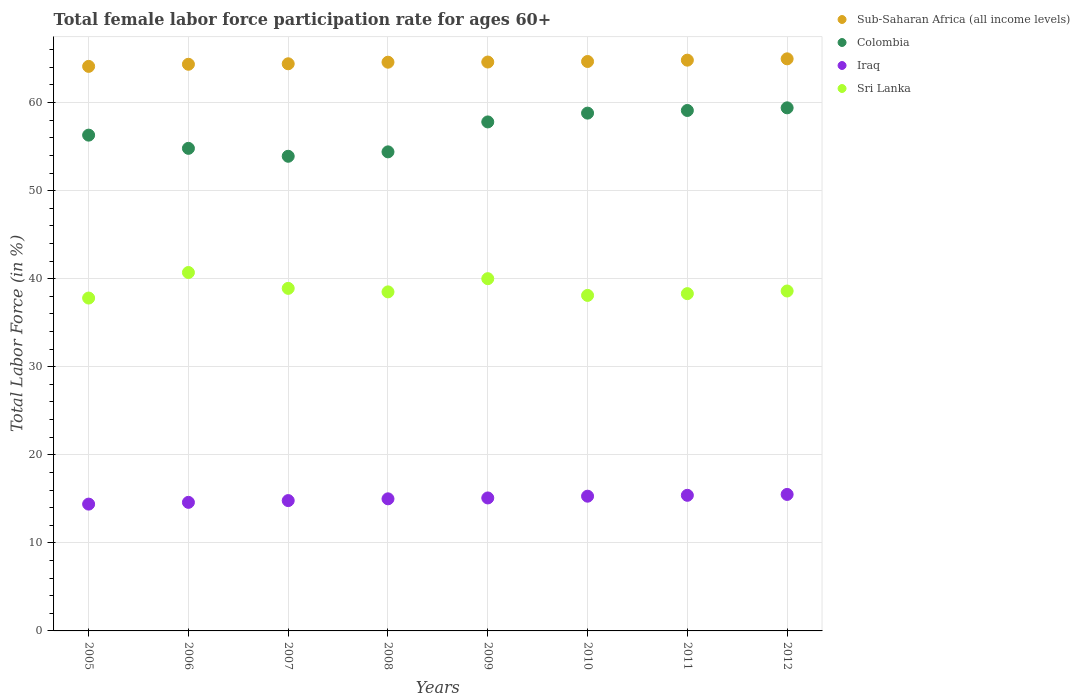How many different coloured dotlines are there?
Offer a very short reply. 4. Is the number of dotlines equal to the number of legend labels?
Ensure brevity in your answer.  Yes. What is the female labor force participation rate in Sub-Saharan Africa (all income levels) in 2010?
Your answer should be compact. 64.66. Across all years, what is the maximum female labor force participation rate in Sri Lanka?
Offer a very short reply. 40.7. Across all years, what is the minimum female labor force participation rate in Sri Lanka?
Ensure brevity in your answer.  37.8. In which year was the female labor force participation rate in Iraq maximum?
Keep it short and to the point. 2012. What is the total female labor force participation rate in Colombia in the graph?
Your answer should be very brief. 454.5. What is the difference between the female labor force participation rate in Sri Lanka in 2007 and that in 2010?
Ensure brevity in your answer.  0.8. What is the difference between the female labor force participation rate in Colombia in 2006 and the female labor force participation rate in Iraq in 2007?
Your answer should be very brief. 40. What is the average female labor force participation rate in Colombia per year?
Provide a short and direct response. 56.81. In the year 2010, what is the difference between the female labor force participation rate in Sri Lanka and female labor force participation rate in Iraq?
Provide a short and direct response. 22.8. What is the ratio of the female labor force participation rate in Sub-Saharan Africa (all income levels) in 2005 to that in 2010?
Make the answer very short. 0.99. Is the difference between the female labor force participation rate in Sri Lanka in 2007 and 2010 greater than the difference between the female labor force participation rate in Iraq in 2007 and 2010?
Make the answer very short. Yes. What is the difference between the highest and the second highest female labor force participation rate in Colombia?
Your answer should be compact. 0.3. What is the difference between the highest and the lowest female labor force participation rate in Iraq?
Offer a very short reply. 1.1. Does the female labor force participation rate in Sri Lanka monotonically increase over the years?
Offer a very short reply. No. Is the female labor force participation rate in Sri Lanka strictly less than the female labor force participation rate in Iraq over the years?
Ensure brevity in your answer.  No. How many dotlines are there?
Ensure brevity in your answer.  4. Where does the legend appear in the graph?
Offer a terse response. Top right. How many legend labels are there?
Offer a very short reply. 4. What is the title of the graph?
Provide a short and direct response. Total female labor force participation rate for ages 60+. What is the Total Labor Force (in %) in Sub-Saharan Africa (all income levels) in 2005?
Make the answer very short. 64.11. What is the Total Labor Force (in %) of Colombia in 2005?
Provide a succinct answer. 56.3. What is the Total Labor Force (in %) of Iraq in 2005?
Offer a very short reply. 14.4. What is the Total Labor Force (in %) of Sri Lanka in 2005?
Give a very brief answer. 37.8. What is the Total Labor Force (in %) of Sub-Saharan Africa (all income levels) in 2006?
Ensure brevity in your answer.  64.35. What is the Total Labor Force (in %) in Colombia in 2006?
Provide a succinct answer. 54.8. What is the Total Labor Force (in %) of Iraq in 2006?
Provide a short and direct response. 14.6. What is the Total Labor Force (in %) of Sri Lanka in 2006?
Give a very brief answer. 40.7. What is the Total Labor Force (in %) of Sub-Saharan Africa (all income levels) in 2007?
Offer a very short reply. 64.4. What is the Total Labor Force (in %) in Colombia in 2007?
Give a very brief answer. 53.9. What is the Total Labor Force (in %) in Iraq in 2007?
Make the answer very short. 14.8. What is the Total Labor Force (in %) of Sri Lanka in 2007?
Your response must be concise. 38.9. What is the Total Labor Force (in %) of Sub-Saharan Africa (all income levels) in 2008?
Keep it short and to the point. 64.58. What is the Total Labor Force (in %) of Colombia in 2008?
Provide a succinct answer. 54.4. What is the Total Labor Force (in %) in Iraq in 2008?
Your answer should be compact. 15. What is the Total Labor Force (in %) in Sri Lanka in 2008?
Provide a short and direct response. 38.5. What is the Total Labor Force (in %) in Sub-Saharan Africa (all income levels) in 2009?
Offer a terse response. 64.6. What is the Total Labor Force (in %) of Colombia in 2009?
Make the answer very short. 57.8. What is the Total Labor Force (in %) of Iraq in 2009?
Provide a short and direct response. 15.1. What is the Total Labor Force (in %) of Sub-Saharan Africa (all income levels) in 2010?
Offer a very short reply. 64.66. What is the Total Labor Force (in %) in Colombia in 2010?
Your answer should be very brief. 58.8. What is the Total Labor Force (in %) in Iraq in 2010?
Your answer should be very brief. 15.3. What is the Total Labor Force (in %) in Sri Lanka in 2010?
Ensure brevity in your answer.  38.1. What is the Total Labor Force (in %) of Sub-Saharan Africa (all income levels) in 2011?
Offer a terse response. 64.81. What is the Total Labor Force (in %) of Colombia in 2011?
Offer a very short reply. 59.1. What is the Total Labor Force (in %) of Iraq in 2011?
Provide a succinct answer. 15.4. What is the Total Labor Force (in %) in Sri Lanka in 2011?
Give a very brief answer. 38.3. What is the Total Labor Force (in %) in Sub-Saharan Africa (all income levels) in 2012?
Give a very brief answer. 64.96. What is the Total Labor Force (in %) in Colombia in 2012?
Your answer should be very brief. 59.4. What is the Total Labor Force (in %) in Sri Lanka in 2012?
Ensure brevity in your answer.  38.6. Across all years, what is the maximum Total Labor Force (in %) in Sub-Saharan Africa (all income levels)?
Your answer should be very brief. 64.96. Across all years, what is the maximum Total Labor Force (in %) of Colombia?
Your answer should be compact. 59.4. Across all years, what is the maximum Total Labor Force (in %) in Sri Lanka?
Offer a very short reply. 40.7. Across all years, what is the minimum Total Labor Force (in %) in Sub-Saharan Africa (all income levels)?
Provide a short and direct response. 64.11. Across all years, what is the minimum Total Labor Force (in %) in Colombia?
Ensure brevity in your answer.  53.9. Across all years, what is the minimum Total Labor Force (in %) in Iraq?
Give a very brief answer. 14.4. Across all years, what is the minimum Total Labor Force (in %) in Sri Lanka?
Provide a succinct answer. 37.8. What is the total Total Labor Force (in %) in Sub-Saharan Africa (all income levels) in the graph?
Provide a short and direct response. 516.49. What is the total Total Labor Force (in %) of Colombia in the graph?
Provide a succinct answer. 454.5. What is the total Total Labor Force (in %) in Iraq in the graph?
Provide a succinct answer. 120.1. What is the total Total Labor Force (in %) of Sri Lanka in the graph?
Ensure brevity in your answer.  310.9. What is the difference between the Total Labor Force (in %) in Sub-Saharan Africa (all income levels) in 2005 and that in 2006?
Ensure brevity in your answer.  -0.24. What is the difference between the Total Labor Force (in %) in Iraq in 2005 and that in 2006?
Give a very brief answer. -0.2. What is the difference between the Total Labor Force (in %) of Sub-Saharan Africa (all income levels) in 2005 and that in 2007?
Make the answer very short. -0.29. What is the difference between the Total Labor Force (in %) of Colombia in 2005 and that in 2007?
Your answer should be very brief. 2.4. What is the difference between the Total Labor Force (in %) of Iraq in 2005 and that in 2007?
Ensure brevity in your answer.  -0.4. What is the difference between the Total Labor Force (in %) of Sub-Saharan Africa (all income levels) in 2005 and that in 2008?
Offer a terse response. -0.48. What is the difference between the Total Labor Force (in %) of Colombia in 2005 and that in 2008?
Your response must be concise. 1.9. What is the difference between the Total Labor Force (in %) in Iraq in 2005 and that in 2008?
Make the answer very short. -0.6. What is the difference between the Total Labor Force (in %) in Sri Lanka in 2005 and that in 2008?
Ensure brevity in your answer.  -0.7. What is the difference between the Total Labor Force (in %) in Sub-Saharan Africa (all income levels) in 2005 and that in 2009?
Your response must be concise. -0.49. What is the difference between the Total Labor Force (in %) in Iraq in 2005 and that in 2009?
Give a very brief answer. -0.7. What is the difference between the Total Labor Force (in %) in Sri Lanka in 2005 and that in 2009?
Provide a succinct answer. -2.2. What is the difference between the Total Labor Force (in %) of Sub-Saharan Africa (all income levels) in 2005 and that in 2010?
Give a very brief answer. -0.56. What is the difference between the Total Labor Force (in %) in Iraq in 2005 and that in 2010?
Your answer should be very brief. -0.9. What is the difference between the Total Labor Force (in %) in Sri Lanka in 2005 and that in 2010?
Your response must be concise. -0.3. What is the difference between the Total Labor Force (in %) in Sub-Saharan Africa (all income levels) in 2005 and that in 2011?
Your response must be concise. -0.71. What is the difference between the Total Labor Force (in %) in Iraq in 2005 and that in 2011?
Offer a terse response. -1. What is the difference between the Total Labor Force (in %) of Sub-Saharan Africa (all income levels) in 2005 and that in 2012?
Your response must be concise. -0.86. What is the difference between the Total Labor Force (in %) in Sri Lanka in 2005 and that in 2012?
Give a very brief answer. -0.8. What is the difference between the Total Labor Force (in %) of Sub-Saharan Africa (all income levels) in 2006 and that in 2007?
Provide a short and direct response. -0.06. What is the difference between the Total Labor Force (in %) in Colombia in 2006 and that in 2007?
Ensure brevity in your answer.  0.9. What is the difference between the Total Labor Force (in %) of Sub-Saharan Africa (all income levels) in 2006 and that in 2008?
Your answer should be compact. -0.24. What is the difference between the Total Labor Force (in %) of Sri Lanka in 2006 and that in 2008?
Keep it short and to the point. 2.2. What is the difference between the Total Labor Force (in %) in Sub-Saharan Africa (all income levels) in 2006 and that in 2009?
Your response must be concise. -0.25. What is the difference between the Total Labor Force (in %) of Colombia in 2006 and that in 2009?
Give a very brief answer. -3. What is the difference between the Total Labor Force (in %) in Iraq in 2006 and that in 2009?
Your answer should be very brief. -0.5. What is the difference between the Total Labor Force (in %) of Sri Lanka in 2006 and that in 2009?
Provide a short and direct response. 0.7. What is the difference between the Total Labor Force (in %) of Sub-Saharan Africa (all income levels) in 2006 and that in 2010?
Your response must be concise. -0.32. What is the difference between the Total Labor Force (in %) in Iraq in 2006 and that in 2010?
Make the answer very short. -0.7. What is the difference between the Total Labor Force (in %) of Sri Lanka in 2006 and that in 2010?
Provide a short and direct response. 2.6. What is the difference between the Total Labor Force (in %) of Sub-Saharan Africa (all income levels) in 2006 and that in 2011?
Your answer should be compact. -0.47. What is the difference between the Total Labor Force (in %) in Sub-Saharan Africa (all income levels) in 2006 and that in 2012?
Provide a succinct answer. -0.62. What is the difference between the Total Labor Force (in %) in Colombia in 2006 and that in 2012?
Provide a succinct answer. -4.6. What is the difference between the Total Labor Force (in %) of Iraq in 2006 and that in 2012?
Your answer should be very brief. -0.9. What is the difference between the Total Labor Force (in %) of Sub-Saharan Africa (all income levels) in 2007 and that in 2008?
Keep it short and to the point. -0.18. What is the difference between the Total Labor Force (in %) of Sri Lanka in 2007 and that in 2008?
Your answer should be very brief. 0.4. What is the difference between the Total Labor Force (in %) of Sub-Saharan Africa (all income levels) in 2007 and that in 2009?
Offer a terse response. -0.2. What is the difference between the Total Labor Force (in %) in Sub-Saharan Africa (all income levels) in 2007 and that in 2010?
Your response must be concise. -0.26. What is the difference between the Total Labor Force (in %) in Sri Lanka in 2007 and that in 2010?
Your response must be concise. 0.8. What is the difference between the Total Labor Force (in %) in Sub-Saharan Africa (all income levels) in 2007 and that in 2011?
Provide a short and direct response. -0.41. What is the difference between the Total Labor Force (in %) of Sub-Saharan Africa (all income levels) in 2007 and that in 2012?
Offer a very short reply. -0.56. What is the difference between the Total Labor Force (in %) of Colombia in 2007 and that in 2012?
Provide a short and direct response. -5.5. What is the difference between the Total Labor Force (in %) of Iraq in 2007 and that in 2012?
Make the answer very short. -0.7. What is the difference between the Total Labor Force (in %) of Sub-Saharan Africa (all income levels) in 2008 and that in 2009?
Offer a terse response. -0.02. What is the difference between the Total Labor Force (in %) in Sri Lanka in 2008 and that in 2009?
Ensure brevity in your answer.  -1.5. What is the difference between the Total Labor Force (in %) in Sub-Saharan Africa (all income levels) in 2008 and that in 2010?
Offer a terse response. -0.08. What is the difference between the Total Labor Force (in %) of Sri Lanka in 2008 and that in 2010?
Provide a short and direct response. 0.4. What is the difference between the Total Labor Force (in %) in Sub-Saharan Africa (all income levels) in 2008 and that in 2011?
Make the answer very short. -0.23. What is the difference between the Total Labor Force (in %) in Colombia in 2008 and that in 2011?
Make the answer very short. -4.7. What is the difference between the Total Labor Force (in %) in Sri Lanka in 2008 and that in 2011?
Ensure brevity in your answer.  0.2. What is the difference between the Total Labor Force (in %) of Sub-Saharan Africa (all income levels) in 2008 and that in 2012?
Offer a terse response. -0.38. What is the difference between the Total Labor Force (in %) in Iraq in 2008 and that in 2012?
Your response must be concise. -0.5. What is the difference between the Total Labor Force (in %) in Sri Lanka in 2008 and that in 2012?
Provide a short and direct response. -0.1. What is the difference between the Total Labor Force (in %) in Sub-Saharan Africa (all income levels) in 2009 and that in 2010?
Provide a succinct answer. -0.06. What is the difference between the Total Labor Force (in %) of Sub-Saharan Africa (all income levels) in 2009 and that in 2011?
Keep it short and to the point. -0.21. What is the difference between the Total Labor Force (in %) in Colombia in 2009 and that in 2011?
Ensure brevity in your answer.  -1.3. What is the difference between the Total Labor Force (in %) in Iraq in 2009 and that in 2011?
Offer a very short reply. -0.3. What is the difference between the Total Labor Force (in %) of Sub-Saharan Africa (all income levels) in 2009 and that in 2012?
Your answer should be compact. -0.36. What is the difference between the Total Labor Force (in %) in Colombia in 2009 and that in 2012?
Provide a succinct answer. -1.6. What is the difference between the Total Labor Force (in %) in Sri Lanka in 2009 and that in 2012?
Offer a very short reply. 1.4. What is the difference between the Total Labor Force (in %) in Sub-Saharan Africa (all income levels) in 2010 and that in 2011?
Your answer should be very brief. -0.15. What is the difference between the Total Labor Force (in %) of Sub-Saharan Africa (all income levels) in 2010 and that in 2012?
Ensure brevity in your answer.  -0.3. What is the difference between the Total Labor Force (in %) in Iraq in 2010 and that in 2012?
Offer a very short reply. -0.2. What is the difference between the Total Labor Force (in %) in Sri Lanka in 2010 and that in 2012?
Your response must be concise. -0.5. What is the difference between the Total Labor Force (in %) of Sub-Saharan Africa (all income levels) in 2011 and that in 2012?
Keep it short and to the point. -0.15. What is the difference between the Total Labor Force (in %) of Colombia in 2011 and that in 2012?
Keep it short and to the point. -0.3. What is the difference between the Total Labor Force (in %) of Sub-Saharan Africa (all income levels) in 2005 and the Total Labor Force (in %) of Colombia in 2006?
Ensure brevity in your answer.  9.31. What is the difference between the Total Labor Force (in %) of Sub-Saharan Africa (all income levels) in 2005 and the Total Labor Force (in %) of Iraq in 2006?
Make the answer very short. 49.51. What is the difference between the Total Labor Force (in %) in Sub-Saharan Africa (all income levels) in 2005 and the Total Labor Force (in %) in Sri Lanka in 2006?
Your answer should be compact. 23.41. What is the difference between the Total Labor Force (in %) in Colombia in 2005 and the Total Labor Force (in %) in Iraq in 2006?
Your response must be concise. 41.7. What is the difference between the Total Labor Force (in %) in Colombia in 2005 and the Total Labor Force (in %) in Sri Lanka in 2006?
Offer a terse response. 15.6. What is the difference between the Total Labor Force (in %) in Iraq in 2005 and the Total Labor Force (in %) in Sri Lanka in 2006?
Ensure brevity in your answer.  -26.3. What is the difference between the Total Labor Force (in %) in Sub-Saharan Africa (all income levels) in 2005 and the Total Labor Force (in %) in Colombia in 2007?
Provide a succinct answer. 10.21. What is the difference between the Total Labor Force (in %) in Sub-Saharan Africa (all income levels) in 2005 and the Total Labor Force (in %) in Iraq in 2007?
Offer a very short reply. 49.31. What is the difference between the Total Labor Force (in %) in Sub-Saharan Africa (all income levels) in 2005 and the Total Labor Force (in %) in Sri Lanka in 2007?
Give a very brief answer. 25.21. What is the difference between the Total Labor Force (in %) in Colombia in 2005 and the Total Labor Force (in %) in Iraq in 2007?
Keep it short and to the point. 41.5. What is the difference between the Total Labor Force (in %) of Colombia in 2005 and the Total Labor Force (in %) of Sri Lanka in 2007?
Keep it short and to the point. 17.4. What is the difference between the Total Labor Force (in %) of Iraq in 2005 and the Total Labor Force (in %) of Sri Lanka in 2007?
Your response must be concise. -24.5. What is the difference between the Total Labor Force (in %) in Sub-Saharan Africa (all income levels) in 2005 and the Total Labor Force (in %) in Colombia in 2008?
Provide a succinct answer. 9.71. What is the difference between the Total Labor Force (in %) in Sub-Saharan Africa (all income levels) in 2005 and the Total Labor Force (in %) in Iraq in 2008?
Offer a very short reply. 49.11. What is the difference between the Total Labor Force (in %) in Sub-Saharan Africa (all income levels) in 2005 and the Total Labor Force (in %) in Sri Lanka in 2008?
Offer a very short reply. 25.61. What is the difference between the Total Labor Force (in %) in Colombia in 2005 and the Total Labor Force (in %) in Iraq in 2008?
Your answer should be compact. 41.3. What is the difference between the Total Labor Force (in %) of Iraq in 2005 and the Total Labor Force (in %) of Sri Lanka in 2008?
Make the answer very short. -24.1. What is the difference between the Total Labor Force (in %) in Sub-Saharan Africa (all income levels) in 2005 and the Total Labor Force (in %) in Colombia in 2009?
Your response must be concise. 6.31. What is the difference between the Total Labor Force (in %) in Sub-Saharan Africa (all income levels) in 2005 and the Total Labor Force (in %) in Iraq in 2009?
Keep it short and to the point. 49.01. What is the difference between the Total Labor Force (in %) of Sub-Saharan Africa (all income levels) in 2005 and the Total Labor Force (in %) of Sri Lanka in 2009?
Your answer should be compact. 24.11. What is the difference between the Total Labor Force (in %) in Colombia in 2005 and the Total Labor Force (in %) in Iraq in 2009?
Offer a terse response. 41.2. What is the difference between the Total Labor Force (in %) in Colombia in 2005 and the Total Labor Force (in %) in Sri Lanka in 2009?
Offer a terse response. 16.3. What is the difference between the Total Labor Force (in %) in Iraq in 2005 and the Total Labor Force (in %) in Sri Lanka in 2009?
Offer a terse response. -25.6. What is the difference between the Total Labor Force (in %) in Sub-Saharan Africa (all income levels) in 2005 and the Total Labor Force (in %) in Colombia in 2010?
Give a very brief answer. 5.31. What is the difference between the Total Labor Force (in %) of Sub-Saharan Africa (all income levels) in 2005 and the Total Labor Force (in %) of Iraq in 2010?
Provide a succinct answer. 48.81. What is the difference between the Total Labor Force (in %) of Sub-Saharan Africa (all income levels) in 2005 and the Total Labor Force (in %) of Sri Lanka in 2010?
Make the answer very short. 26.01. What is the difference between the Total Labor Force (in %) of Iraq in 2005 and the Total Labor Force (in %) of Sri Lanka in 2010?
Offer a very short reply. -23.7. What is the difference between the Total Labor Force (in %) of Sub-Saharan Africa (all income levels) in 2005 and the Total Labor Force (in %) of Colombia in 2011?
Provide a succinct answer. 5.01. What is the difference between the Total Labor Force (in %) in Sub-Saharan Africa (all income levels) in 2005 and the Total Labor Force (in %) in Iraq in 2011?
Provide a succinct answer. 48.71. What is the difference between the Total Labor Force (in %) in Sub-Saharan Africa (all income levels) in 2005 and the Total Labor Force (in %) in Sri Lanka in 2011?
Your response must be concise. 25.81. What is the difference between the Total Labor Force (in %) in Colombia in 2005 and the Total Labor Force (in %) in Iraq in 2011?
Your response must be concise. 40.9. What is the difference between the Total Labor Force (in %) in Colombia in 2005 and the Total Labor Force (in %) in Sri Lanka in 2011?
Provide a succinct answer. 18. What is the difference between the Total Labor Force (in %) in Iraq in 2005 and the Total Labor Force (in %) in Sri Lanka in 2011?
Give a very brief answer. -23.9. What is the difference between the Total Labor Force (in %) in Sub-Saharan Africa (all income levels) in 2005 and the Total Labor Force (in %) in Colombia in 2012?
Provide a succinct answer. 4.71. What is the difference between the Total Labor Force (in %) of Sub-Saharan Africa (all income levels) in 2005 and the Total Labor Force (in %) of Iraq in 2012?
Provide a short and direct response. 48.61. What is the difference between the Total Labor Force (in %) in Sub-Saharan Africa (all income levels) in 2005 and the Total Labor Force (in %) in Sri Lanka in 2012?
Provide a short and direct response. 25.51. What is the difference between the Total Labor Force (in %) in Colombia in 2005 and the Total Labor Force (in %) in Iraq in 2012?
Provide a succinct answer. 40.8. What is the difference between the Total Labor Force (in %) of Colombia in 2005 and the Total Labor Force (in %) of Sri Lanka in 2012?
Your answer should be compact. 17.7. What is the difference between the Total Labor Force (in %) in Iraq in 2005 and the Total Labor Force (in %) in Sri Lanka in 2012?
Your response must be concise. -24.2. What is the difference between the Total Labor Force (in %) of Sub-Saharan Africa (all income levels) in 2006 and the Total Labor Force (in %) of Colombia in 2007?
Make the answer very short. 10.45. What is the difference between the Total Labor Force (in %) of Sub-Saharan Africa (all income levels) in 2006 and the Total Labor Force (in %) of Iraq in 2007?
Offer a terse response. 49.55. What is the difference between the Total Labor Force (in %) in Sub-Saharan Africa (all income levels) in 2006 and the Total Labor Force (in %) in Sri Lanka in 2007?
Ensure brevity in your answer.  25.45. What is the difference between the Total Labor Force (in %) of Iraq in 2006 and the Total Labor Force (in %) of Sri Lanka in 2007?
Offer a terse response. -24.3. What is the difference between the Total Labor Force (in %) in Sub-Saharan Africa (all income levels) in 2006 and the Total Labor Force (in %) in Colombia in 2008?
Make the answer very short. 9.95. What is the difference between the Total Labor Force (in %) of Sub-Saharan Africa (all income levels) in 2006 and the Total Labor Force (in %) of Iraq in 2008?
Give a very brief answer. 49.35. What is the difference between the Total Labor Force (in %) of Sub-Saharan Africa (all income levels) in 2006 and the Total Labor Force (in %) of Sri Lanka in 2008?
Keep it short and to the point. 25.85. What is the difference between the Total Labor Force (in %) of Colombia in 2006 and the Total Labor Force (in %) of Iraq in 2008?
Your answer should be very brief. 39.8. What is the difference between the Total Labor Force (in %) in Iraq in 2006 and the Total Labor Force (in %) in Sri Lanka in 2008?
Offer a very short reply. -23.9. What is the difference between the Total Labor Force (in %) in Sub-Saharan Africa (all income levels) in 2006 and the Total Labor Force (in %) in Colombia in 2009?
Offer a very short reply. 6.55. What is the difference between the Total Labor Force (in %) in Sub-Saharan Africa (all income levels) in 2006 and the Total Labor Force (in %) in Iraq in 2009?
Your response must be concise. 49.25. What is the difference between the Total Labor Force (in %) of Sub-Saharan Africa (all income levels) in 2006 and the Total Labor Force (in %) of Sri Lanka in 2009?
Your answer should be very brief. 24.35. What is the difference between the Total Labor Force (in %) of Colombia in 2006 and the Total Labor Force (in %) of Iraq in 2009?
Your answer should be compact. 39.7. What is the difference between the Total Labor Force (in %) of Colombia in 2006 and the Total Labor Force (in %) of Sri Lanka in 2009?
Make the answer very short. 14.8. What is the difference between the Total Labor Force (in %) of Iraq in 2006 and the Total Labor Force (in %) of Sri Lanka in 2009?
Provide a short and direct response. -25.4. What is the difference between the Total Labor Force (in %) of Sub-Saharan Africa (all income levels) in 2006 and the Total Labor Force (in %) of Colombia in 2010?
Provide a short and direct response. 5.55. What is the difference between the Total Labor Force (in %) in Sub-Saharan Africa (all income levels) in 2006 and the Total Labor Force (in %) in Iraq in 2010?
Offer a terse response. 49.05. What is the difference between the Total Labor Force (in %) of Sub-Saharan Africa (all income levels) in 2006 and the Total Labor Force (in %) of Sri Lanka in 2010?
Offer a terse response. 26.25. What is the difference between the Total Labor Force (in %) in Colombia in 2006 and the Total Labor Force (in %) in Iraq in 2010?
Make the answer very short. 39.5. What is the difference between the Total Labor Force (in %) of Iraq in 2006 and the Total Labor Force (in %) of Sri Lanka in 2010?
Provide a succinct answer. -23.5. What is the difference between the Total Labor Force (in %) of Sub-Saharan Africa (all income levels) in 2006 and the Total Labor Force (in %) of Colombia in 2011?
Provide a short and direct response. 5.25. What is the difference between the Total Labor Force (in %) in Sub-Saharan Africa (all income levels) in 2006 and the Total Labor Force (in %) in Iraq in 2011?
Your response must be concise. 48.95. What is the difference between the Total Labor Force (in %) in Sub-Saharan Africa (all income levels) in 2006 and the Total Labor Force (in %) in Sri Lanka in 2011?
Offer a very short reply. 26.05. What is the difference between the Total Labor Force (in %) of Colombia in 2006 and the Total Labor Force (in %) of Iraq in 2011?
Your response must be concise. 39.4. What is the difference between the Total Labor Force (in %) in Iraq in 2006 and the Total Labor Force (in %) in Sri Lanka in 2011?
Your answer should be very brief. -23.7. What is the difference between the Total Labor Force (in %) in Sub-Saharan Africa (all income levels) in 2006 and the Total Labor Force (in %) in Colombia in 2012?
Your answer should be very brief. 4.95. What is the difference between the Total Labor Force (in %) in Sub-Saharan Africa (all income levels) in 2006 and the Total Labor Force (in %) in Iraq in 2012?
Give a very brief answer. 48.85. What is the difference between the Total Labor Force (in %) in Sub-Saharan Africa (all income levels) in 2006 and the Total Labor Force (in %) in Sri Lanka in 2012?
Your answer should be compact. 25.75. What is the difference between the Total Labor Force (in %) of Colombia in 2006 and the Total Labor Force (in %) of Iraq in 2012?
Keep it short and to the point. 39.3. What is the difference between the Total Labor Force (in %) in Sub-Saharan Africa (all income levels) in 2007 and the Total Labor Force (in %) in Colombia in 2008?
Give a very brief answer. 10. What is the difference between the Total Labor Force (in %) of Sub-Saharan Africa (all income levels) in 2007 and the Total Labor Force (in %) of Iraq in 2008?
Your response must be concise. 49.4. What is the difference between the Total Labor Force (in %) of Sub-Saharan Africa (all income levels) in 2007 and the Total Labor Force (in %) of Sri Lanka in 2008?
Give a very brief answer. 25.9. What is the difference between the Total Labor Force (in %) in Colombia in 2007 and the Total Labor Force (in %) in Iraq in 2008?
Your answer should be compact. 38.9. What is the difference between the Total Labor Force (in %) in Iraq in 2007 and the Total Labor Force (in %) in Sri Lanka in 2008?
Provide a succinct answer. -23.7. What is the difference between the Total Labor Force (in %) of Sub-Saharan Africa (all income levels) in 2007 and the Total Labor Force (in %) of Colombia in 2009?
Provide a succinct answer. 6.6. What is the difference between the Total Labor Force (in %) in Sub-Saharan Africa (all income levels) in 2007 and the Total Labor Force (in %) in Iraq in 2009?
Provide a succinct answer. 49.3. What is the difference between the Total Labor Force (in %) in Sub-Saharan Africa (all income levels) in 2007 and the Total Labor Force (in %) in Sri Lanka in 2009?
Ensure brevity in your answer.  24.4. What is the difference between the Total Labor Force (in %) in Colombia in 2007 and the Total Labor Force (in %) in Iraq in 2009?
Ensure brevity in your answer.  38.8. What is the difference between the Total Labor Force (in %) in Colombia in 2007 and the Total Labor Force (in %) in Sri Lanka in 2009?
Provide a succinct answer. 13.9. What is the difference between the Total Labor Force (in %) of Iraq in 2007 and the Total Labor Force (in %) of Sri Lanka in 2009?
Provide a short and direct response. -25.2. What is the difference between the Total Labor Force (in %) in Sub-Saharan Africa (all income levels) in 2007 and the Total Labor Force (in %) in Colombia in 2010?
Your answer should be compact. 5.6. What is the difference between the Total Labor Force (in %) in Sub-Saharan Africa (all income levels) in 2007 and the Total Labor Force (in %) in Iraq in 2010?
Keep it short and to the point. 49.1. What is the difference between the Total Labor Force (in %) of Sub-Saharan Africa (all income levels) in 2007 and the Total Labor Force (in %) of Sri Lanka in 2010?
Offer a very short reply. 26.3. What is the difference between the Total Labor Force (in %) of Colombia in 2007 and the Total Labor Force (in %) of Iraq in 2010?
Keep it short and to the point. 38.6. What is the difference between the Total Labor Force (in %) of Colombia in 2007 and the Total Labor Force (in %) of Sri Lanka in 2010?
Offer a very short reply. 15.8. What is the difference between the Total Labor Force (in %) of Iraq in 2007 and the Total Labor Force (in %) of Sri Lanka in 2010?
Your answer should be compact. -23.3. What is the difference between the Total Labor Force (in %) in Sub-Saharan Africa (all income levels) in 2007 and the Total Labor Force (in %) in Colombia in 2011?
Your answer should be compact. 5.3. What is the difference between the Total Labor Force (in %) in Sub-Saharan Africa (all income levels) in 2007 and the Total Labor Force (in %) in Iraq in 2011?
Offer a terse response. 49. What is the difference between the Total Labor Force (in %) in Sub-Saharan Africa (all income levels) in 2007 and the Total Labor Force (in %) in Sri Lanka in 2011?
Your answer should be very brief. 26.1. What is the difference between the Total Labor Force (in %) in Colombia in 2007 and the Total Labor Force (in %) in Iraq in 2011?
Your answer should be compact. 38.5. What is the difference between the Total Labor Force (in %) of Iraq in 2007 and the Total Labor Force (in %) of Sri Lanka in 2011?
Provide a short and direct response. -23.5. What is the difference between the Total Labor Force (in %) of Sub-Saharan Africa (all income levels) in 2007 and the Total Labor Force (in %) of Colombia in 2012?
Offer a terse response. 5. What is the difference between the Total Labor Force (in %) of Sub-Saharan Africa (all income levels) in 2007 and the Total Labor Force (in %) of Iraq in 2012?
Provide a short and direct response. 48.9. What is the difference between the Total Labor Force (in %) in Sub-Saharan Africa (all income levels) in 2007 and the Total Labor Force (in %) in Sri Lanka in 2012?
Keep it short and to the point. 25.8. What is the difference between the Total Labor Force (in %) in Colombia in 2007 and the Total Labor Force (in %) in Iraq in 2012?
Provide a short and direct response. 38.4. What is the difference between the Total Labor Force (in %) of Iraq in 2007 and the Total Labor Force (in %) of Sri Lanka in 2012?
Provide a short and direct response. -23.8. What is the difference between the Total Labor Force (in %) in Sub-Saharan Africa (all income levels) in 2008 and the Total Labor Force (in %) in Colombia in 2009?
Ensure brevity in your answer.  6.78. What is the difference between the Total Labor Force (in %) of Sub-Saharan Africa (all income levels) in 2008 and the Total Labor Force (in %) of Iraq in 2009?
Make the answer very short. 49.48. What is the difference between the Total Labor Force (in %) of Sub-Saharan Africa (all income levels) in 2008 and the Total Labor Force (in %) of Sri Lanka in 2009?
Your answer should be compact. 24.58. What is the difference between the Total Labor Force (in %) in Colombia in 2008 and the Total Labor Force (in %) in Iraq in 2009?
Your answer should be compact. 39.3. What is the difference between the Total Labor Force (in %) in Colombia in 2008 and the Total Labor Force (in %) in Sri Lanka in 2009?
Your answer should be compact. 14.4. What is the difference between the Total Labor Force (in %) of Iraq in 2008 and the Total Labor Force (in %) of Sri Lanka in 2009?
Give a very brief answer. -25. What is the difference between the Total Labor Force (in %) in Sub-Saharan Africa (all income levels) in 2008 and the Total Labor Force (in %) in Colombia in 2010?
Provide a succinct answer. 5.78. What is the difference between the Total Labor Force (in %) of Sub-Saharan Africa (all income levels) in 2008 and the Total Labor Force (in %) of Iraq in 2010?
Your response must be concise. 49.28. What is the difference between the Total Labor Force (in %) in Sub-Saharan Africa (all income levels) in 2008 and the Total Labor Force (in %) in Sri Lanka in 2010?
Keep it short and to the point. 26.48. What is the difference between the Total Labor Force (in %) of Colombia in 2008 and the Total Labor Force (in %) of Iraq in 2010?
Your answer should be compact. 39.1. What is the difference between the Total Labor Force (in %) of Iraq in 2008 and the Total Labor Force (in %) of Sri Lanka in 2010?
Provide a short and direct response. -23.1. What is the difference between the Total Labor Force (in %) in Sub-Saharan Africa (all income levels) in 2008 and the Total Labor Force (in %) in Colombia in 2011?
Ensure brevity in your answer.  5.48. What is the difference between the Total Labor Force (in %) of Sub-Saharan Africa (all income levels) in 2008 and the Total Labor Force (in %) of Iraq in 2011?
Keep it short and to the point. 49.18. What is the difference between the Total Labor Force (in %) of Sub-Saharan Africa (all income levels) in 2008 and the Total Labor Force (in %) of Sri Lanka in 2011?
Provide a succinct answer. 26.28. What is the difference between the Total Labor Force (in %) of Iraq in 2008 and the Total Labor Force (in %) of Sri Lanka in 2011?
Your response must be concise. -23.3. What is the difference between the Total Labor Force (in %) in Sub-Saharan Africa (all income levels) in 2008 and the Total Labor Force (in %) in Colombia in 2012?
Your answer should be very brief. 5.18. What is the difference between the Total Labor Force (in %) of Sub-Saharan Africa (all income levels) in 2008 and the Total Labor Force (in %) of Iraq in 2012?
Give a very brief answer. 49.08. What is the difference between the Total Labor Force (in %) of Sub-Saharan Africa (all income levels) in 2008 and the Total Labor Force (in %) of Sri Lanka in 2012?
Your answer should be very brief. 25.98. What is the difference between the Total Labor Force (in %) of Colombia in 2008 and the Total Labor Force (in %) of Iraq in 2012?
Provide a short and direct response. 38.9. What is the difference between the Total Labor Force (in %) in Colombia in 2008 and the Total Labor Force (in %) in Sri Lanka in 2012?
Provide a short and direct response. 15.8. What is the difference between the Total Labor Force (in %) of Iraq in 2008 and the Total Labor Force (in %) of Sri Lanka in 2012?
Make the answer very short. -23.6. What is the difference between the Total Labor Force (in %) in Sub-Saharan Africa (all income levels) in 2009 and the Total Labor Force (in %) in Colombia in 2010?
Offer a very short reply. 5.8. What is the difference between the Total Labor Force (in %) in Sub-Saharan Africa (all income levels) in 2009 and the Total Labor Force (in %) in Iraq in 2010?
Offer a terse response. 49.3. What is the difference between the Total Labor Force (in %) of Sub-Saharan Africa (all income levels) in 2009 and the Total Labor Force (in %) of Sri Lanka in 2010?
Your answer should be very brief. 26.5. What is the difference between the Total Labor Force (in %) of Colombia in 2009 and the Total Labor Force (in %) of Iraq in 2010?
Keep it short and to the point. 42.5. What is the difference between the Total Labor Force (in %) in Colombia in 2009 and the Total Labor Force (in %) in Sri Lanka in 2010?
Offer a very short reply. 19.7. What is the difference between the Total Labor Force (in %) in Iraq in 2009 and the Total Labor Force (in %) in Sri Lanka in 2010?
Your answer should be very brief. -23. What is the difference between the Total Labor Force (in %) of Sub-Saharan Africa (all income levels) in 2009 and the Total Labor Force (in %) of Colombia in 2011?
Give a very brief answer. 5.5. What is the difference between the Total Labor Force (in %) in Sub-Saharan Africa (all income levels) in 2009 and the Total Labor Force (in %) in Iraq in 2011?
Provide a short and direct response. 49.2. What is the difference between the Total Labor Force (in %) in Sub-Saharan Africa (all income levels) in 2009 and the Total Labor Force (in %) in Sri Lanka in 2011?
Give a very brief answer. 26.3. What is the difference between the Total Labor Force (in %) of Colombia in 2009 and the Total Labor Force (in %) of Iraq in 2011?
Ensure brevity in your answer.  42.4. What is the difference between the Total Labor Force (in %) of Colombia in 2009 and the Total Labor Force (in %) of Sri Lanka in 2011?
Offer a very short reply. 19.5. What is the difference between the Total Labor Force (in %) of Iraq in 2009 and the Total Labor Force (in %) of Sri Lanka in 2011?
Your response must be concise. -23.2. What is the difference between the Total Labor Force (in %) in Sub-Saharan Africa (all income levels) in 2009 and the Total Labor Force (in %) in Colombia in 2012?
Provide a succinct answer. 5.2. What is the difference between the Total Labor Force (in %) in Sub-Saharan Africa (all income levels) in 2009 and the Total Labor Force (in %) in Iraq in 2012?
Your answer should be compact. 49.1. What is the difference between the Total Labor Force (in %) in Sub-Saharan Africa (all income levels) in 2009 and the Total Labor Force (in %) in Sri Lanka in 2012?
Give a very brief answer. 26. What is the difference between the Total Labor Force (in %) of Colombia in 2009 and the Total Labor Force (in %) of Iraq in 2012?
Your answer should be very brief. 42.3. What is the difference between the Total Labor Force (in %) of Iraq in 2009 and the Total Labor Force (in %) of Sri Lanka in 2012?
Your answer should be compact. -23.5. What is the difference between the Total Labor Force (in %) in Sub-Saharan Africa (all income levels) in 2010 and the Total Labor Force (in %) in Colombia in 2011?
Your response must be concise. 5.56. What is the difference between the Total Labor Force (in %) in Sub-Saharan Africa (all income levels) in 2010 and the Total Labor Force (in %) in Iraq in 2011?
Make the answer very short. 49.26. What is the difference between the Total Labor Force (in %) of Sub-Saharan Africa (all income levels) in 2010 and the Total Labor Force (in %) of Sri Lanka in 2011?
Your answer should be compact. 26.36. What is the difference between the Total Labor Force (in %) in Colombia in 2010 and the Total Labor Force (in %) in Iraq in 2011?
Provide a succinct answer. 43.4. What is the difference between the Total Labor Force (in %) of Iraq in 2010 and the Total Labor Force (in %) of Sri Lanka in 2011?
Your answer should be compact. -23. What is the difference between the Total Labor Force (in %) of Sub-Saharan Africa (all income levels) in 2010 and the Total Labor Force (in %) of Colombia in 2012?
Keep it short and to the point. 5.26. What is the difference between the Total Labor Force (in %) in Sub-Saharan Africa (all income levels) in 2010 and the Total Labor Force (in %) in Iraq in 2012?
Provide a short and direct response. 49.16. What is the difference between the Total Labor Force (in %) in Sub-Saharan Africa (all income levels) in 2010 and the Total Labor Force (in %) in Sri Lanka in 2012?
Give a very brief answer. 26.06. What is the difference between the Total Labor Force (in %) in Colombia in 2010 and the Total Labor Force (in %) in Iraq in 2012?
Offer a terse response. 43.3. What is the difference between the Total Labor Force (in %) of Colombia in 2010 and the Total Labor Force (in %) of Sri Lanka in 2012?
Give a very brief answer. 20.2. What is the difference between the Total Labor Force (in %) of Iraq in 2010 and the Total Labor Force (in %) of Sri Lanka in 2012?
Keep it short and to the point. -23.3. What is the difference between the Total Labor Force (in %) of Sub-Saharan Africa (all income levels) in 2011 and the Total Labor Force (in %) of Colombia in 2012?
Make the answer very short. 5.41. What is the difference between the Total Labor Force (in %) in Sub-Saharan Africa (all income levels) in 2011 and the Total Labor Force (in %) in Iraq in 2012?
Your answer should be very brief. 49.31. What is the difference between the Total Labor Force (in %) of Sub-Saharan Africa (all income levels) in 2011 and the Total Labor Force (in %) of Sri Lanka in 2012?
Ensure brevity in your answer.  26.21. What is the difference between the Total Labor Force (in %) of Colombia in 2011 and the Total Labor Force (in %) of Iraq in 2012?
Your answer should be very brief. 43.6. What is the difference between the Total Labor Force (in %) of Colombia in 2011 and the Total Labor Force (in %) of Sri Lanka in 2012?
Keep it short and to the point. 20.5. What is the difference between the Total Labor Force (in %) of Iraq in 2011 and the Total Labor Force (in %) of Sri Lanka in 2012?
Make the answer very short. -23.2. What is the average Total Labor Force (in %) in Sub-Saharan Africa (all income levels) per year?
Provide a short and direct response. 64.56. What is the average Total Labor Force (in %) in Colombia per year?
Ensure brevity in your answer.  56.81. What is the average Total Labor Force (in %) of Iraq per year?
Offer a very short reply. 15.01. What is the average Total Labor Force (in %) in Sri Lanka per year?
Ensure brevity in your answer.  38.86. In the year 2005, what is the difference between the Total Labor Force (in %) in Sub-Saharan Africa (all income levels) and Total Labor Force (in %) in Colombia?
Your response must be concise. 7.81. In the year 2005, what is the difference between the Total Labor Force (in %) of Sub-Saharan Africa (all income levels) and Total Labor Force (in %) of Iraq?
Give a very brief answer. 49.71. In the year 2005, what is the difference between the Total Labor Force (in %) of Sub-Saharan Africa (all income levels) and Total Labor Force (in %) of Sri Lanka?
Offer a very short reply. 26.31. In the year 2005, what is the difference between the Total Labor Force (in %) of Colombia and Total Labor Force (in %) of Iraq?
Ensure brevity in your answer.  41.9. In the year 2005, what is the difference between the Total Labor Force (in %) in Colombia and Total Labor Force (in %) in Sri Lanka?
Your response must be concise. 18.5. In the year 2005, what is the difference between the Total Labor Force (in %) in Iraq and Total Labor Force (in %) in Sri Lanka?
Offer a very short reply. -23.4. In the year 2006, what is the difference between the Total Labor Force (in %) of Sub-Saharan Africa (all income levels) and Total Labor Force (in %) of Colombia?
Give a very brief answer. 9.55. In the year 2006, what is the difference between the Total Labor Force (in %) of Sub-Saharan Africa (all income levels) and Total Labor Force (in %) of Iraq?
Your answer should be very brief. 49.75. In the year 2006, what is the difference between the Total Labor Force (in %) in Sub-Saharan Africa (all income levels) and Total Labor Force (in %) in Sri Lanka?
Your answer should be very brief. 23.65. In the year 2006, what is the difference between the Total Labor Force (in %) of Colombia and Total Labor Force (in %) of Iraq?
Offer a terse response. 40.2. In the year 2006, what is the difference between the Total Labor Force (in %) in Iraq and Total Labor Force (in %) in Sri Lanka?
Your response must be concise. -26.1. In the year 2007, what is the difference between the Total Labor Force (in %) of Sub-Saharan Africa (all income levels) and Total Labor Force (in %) of Colombia?
Your answer should be compact. 10.5. In the year 2007, what is the difference between the Total Labor Force (in %) of Sub-Saharan Africa (all income levels) and Total Labor Force (in %) of Iraq?
Give a very brief answer. 49.6. In the year 2007, what is the difference between the Total Labor Force (in %) in Sub-Saharan Africa (all income levels) and Total Labor Force (in %) in Sri Lanka?
Offer a terse response. 25.5. In the year 2007, what is the difference between the Total Labor Force (in %) in Colombia and Total Labor Force (in %) in Iraq?
Offer a terse response. 39.1. In the year 2007, what is the difference between the Total Labor Force (in %) in Iraq and Total Labor Force (in %) in Sri Lanka?
Provide a short and direct response. -24.1. In the year 2008, what is the difference between the Total Labor Force (in %) of Sub-Saharan Africa (all income levels) and Total Labor Force (in %) of Colombia?
Offer a terse response. 10.18. In the year 2008, what is the difference between the Total Labor Force (in %) in Sub-Saharan Africa (all income levels) and Total Labor Force (in %) in Iraq?
Give a very brief answer. 49.58. In the year 2008, what is the difference between the Total Labor Force (in %) in Sub-Saharan Africa (all income levels) and Total Labor Force (in %) in Sri Lanka?
Provide a short and direct response. 26.08. In the year 2008, what is the difference between the Total Labor Force (in %) of Colombia and Total Labor Force (in %) of Iraq?
Offer a very short reply. 39.4. In the year 2008, what is the difference between the Total Labor Force (in %) of Colombia and Total Labor Force (in %) of Sri Lanka?
Offer a very short reply. 15.9. In the year 2008, what is the difference between the Total Labor Force (in %) in Iraq and Total Labor Force (in %) in Sri Lanka?
Keep it short and to the point. -23.5. In the year 2009, what is the difference between the Total Labor Force (in %) of Sub-Saharan Africa (all income levels) and Total Labor Force (in %) of Colombia?
Make the answer very short. 6.8. In the year 2009, what is the difference between the Total Labor Force (in %) of Sub-Saharan Africa (all income levels) and Total Labor Force (in %) of Iraq?
Your response must be concise. 49.5. In the year 2009, what is the difference between the Total Labor Force (in %) of Sub-Saharan Africa (all income levels) and Total Labor Force (in %) of Sri Lanka?
Your answer should be compact. 24.6. In the year 2009, what is the difference between the Total Labor Force (in %) of Colombia and Total Labor Force (in %) of Iraq?
Provide a short and direct response. 42.7. In the year 2009, what is the difference between the Total Labor Force (in %) in Iraq and Total Labor Force (in %) in Sri Lanka?
Ensure brevity in your answer.  -24.9. In the year 2010, what is the difference between the Total Labor Force (in %) in Sub-Saharan Africa (all income levels) and Total Labor Force (in %) in Colombia?
Offer a very short reply. 5.86. In the year 2010, what is the difference between the Total Labor Force (in %) in Sub-Saharan Africa (all income levels) and Total Labor Force (in %) in Iraq?
Your response must be concise. 49.36. In the year 2010, what is the difference between the Total Labor Force (in %) in Sub-Saharan Africa (all income levels) and Total Labor Force (in %) in Sri Lanka?
Offer a terse response. 26.56. In the year 2010, what is the difference between the Total Labor Force (in %) of Colombia and Total Labor Force (in %) of Iraq?
Offer a terse response. 43.5. In the year 2010, what is the difference between the Total Labor Force (in %) in Colombia and Total Labor Force (in %) in Sri Lanka?
Provide a short and direct response. 20.7. In the year 2010, what is the difference between the Total Labor Force (in %) of Iraq and Total Labor Force (in %) of Sri Lanka?
Your answer should be very brief. -22.8. In the year 2011, what is the difference between the Total Labor Force (in %) in Sub-Saharan Africa (all income levels) and Total Labor Force (in %) in Colombia?
Your response must be concise. 5.71. In the year 2011, what is the difference between the Total Labor Force (in %) of Sub-Saharan Africa (all income levels) and Total Labor Force (in %) of Iraq?
Your answer should be compact. 49.41. In the year 2011, what is the difference between the Total Labor Force (in %) of Sub-Saharan Africa (all income levels) and Total Labor Force (in %) of Sri Lanka?
Offer a very short reply. 26.51. In the year 2011, what is the difference between the Total Labor Force (in %) of Colombia and Total Labor Force (in %) of Iraq?
Ensure brevity in your answer.  43.7. In the year 2011, what is the difference between the Total Labor Force (in %) of Colombia and Total Labor Force (in %) of Sri Lanka?
Make the answer very short. 20.8. In the year 2011, what is the difference between the Total Labor Force (in %) of Iraq and Total Labor Force (in %) of Sri Lanka?
Your answer should be very brief. -22.9. In the year 2012, what is the difference between the Total Labor Force (in %) of Sub-Saharan Africa (all income levels) and Total Labor Force (in %) of Colombia?
Make the answer very short. 5.56. In the year 2012, what is the difference between the Total Labor Force (in %) of Sub-Saharan Africa (all income levels) and Total Labor Force (in %) of Iraq?
Provide a succinct answer. 49.46. In the year 2012, what is the difference between the Total Labor Force (in %) of Sub-Saharan Africa (all income levels) and Total Labor Force (in %) of Sri Lanka?
Provide a short and direct response. 26.36. In the year 2012, what is the difference between the Total Labor Force (in %) of Colombia and Total Labor Force (in %) of Iraq?
Your answer should be very brief. 43.9. In the year 2012, what is the difference between the Total Labor Force (in %) of Colombia and Total Labor Force (in %) of Sri Lanka?
Provide a succinct answer. 20.8. In the year 2012, what is the difference between the Total Labor Force (in %) of Iraq and Total Labor Force (in %) of Sri Lanka?
Offer a terse response. -23.1. What is the ratio of the Total Labor Force (in %) in Sub-Saharan Africa (all income levels) in 2005 to that in 2006?
Your answer should be compact. 1. What is the ratio of the Total Labor Force (in %) of Colombia in 2005 to that in 2006?
Keep it short and to the point. 1.03. What is the ratio of the Total Labor Force (in %) in Iraq in 2005 to that in 2006?
Provide a succinct answer. 0.99. What is the ratio of the Total Labor Force (in %) in Sri Lanka in 2005 to that in 2006?
Offer a terse response. 0.93. What is the ratio of the Total Labor Force (in %) of Colombia in 2005 to that in 2007?
Ensure brevity in your answer.  1.04. What is the ratio of the Total Labor Force (in %) in Sri Lanka in 2005 to that in 2007?
Your response must be concise. 0.97. What is the ratio of the Total Labor Force (in %) of Sub-Saharan Africa (all income levels) in 2005 to that in 2008?
Make the answer very short. 0.99. What is the ratio of the Total Labor Force (in %) of Colombia in 2005 to that in 2008?
Give a very brief answer. 1.03. What is the ratio of the Total Labor Force (in %) of Sri Lanka in 2005 to that in 2008?
Your answer should be compact. 0.98. What is the ratio of the Total Labor Force (in %) of Sub-Saharan Africa (all income levels) in 2005 to that in 2009?
Your answer should be very brief. 0.99. What is the ratio of the Total Labor Force (in %) in Iraq in 2005 to that in 2009?
Your answer should be compact. 0.95. What is the ratio of the Total Labor Force (in %) of Sri Lanka in 2005 to that in 2009?
Provide a succinct answer. 0.94. What is the ratio of the Total Labor Force (in %) of Colombia in 2005 to that in 2010?
Your answer should be very brief. 0.96. What is the ratio of the Total Labor Force (in %) of Iraq in 2005 to that in 2010?
Provide a short and direct response. 0.94. What is the ratio of the Total Labor Force (in %) of Sub-Saharan Africa (all income levels) in 2005 to that in 2011?
Provide a succinct answer. 0.99. What is the ratio of the Total Labor Force (in %) of Colombia in 2005 to that in 2011?
Make the answer very short. 0.95. What is the ratio of the Total Labor Force (in %) of Iraq in 2005 to that in 2011?
Offer a terse response. 0.94. What is the ratio of the Total Labor Force (in %) in Sri Lanka in 2005 to that in 2011?
Your answer should be compact. 0.99. What is the ratio of the Total Labor Force (in %) of Colombia in 2005 to that in 2012?
Offer a terse response. 0.95. What is the ratio of the Total Labor Force (in %) of Iraq in 2005 to that in 2012?
Make the answer very short. 0.93. What is the ratio of the Total Labor Force (in %) of Sri Lanka in 2005 to that in 2012?
Give a very brief answer. 0.98. What is the ratio of the Total Labor Force (in %) of Sub-Saharan Africa (all income levels) in 2006 to that in 2007?
Give a very brief answer. 1. What is the ratio of the Total Labor Force (in %) of Colombia in 2006 to that in 2007?
Give a very brief answer. 1.02. What is the ratio of the Total Labor Force (in %) of Iraq in 2006 to that in 2007?
Your answer should be very brief. 0.99. What is the ratio of the Total Labor Force (in %) in Sri Lanka in 2006 to that in 2007?
Give a very brief answer. 1.05. What is the ratio of the Total Labor Force (in %) in Sub-Saharan Africa (all income levels) in 2006 to that in 2008?
Offer a terse response. 1. What is the ratio of the Total Labor Force (in %) of Colombia in 2006 to that in 2008?
Provide a succinct answer. 1.01. What is the ratio of the Total Labor Force (in %) in Iraq in 2006 to that in 2008?
Offer a terse response. 0.97. What is the ratio of the Total Labor Force (in %) of Sri Lanka in 2006 to that in 2008?
Provide a short and direct response. 1.06. What is the ratio of the Total Labor Force (in %) of Colombia in 2006 to that in 2009?
Give a very brief answer. 0.95. What is the ratio of the Total Labor Force (in %) of Iraq in 2006 to that in 2009?
Offer a terse response. 0.97. What is the ratio of the Total Labor Force (in %) of Sri Lanka in 2006 to that in 2009?
Give a very brief answer. 1.02. What is the ratio of the Total Labor Force (in %) of Sub-Saharan Africa (all income levels) in 2006 to that in 2010?
Your answer should be very brief. 1. What is the ratio of the Total Labor Force (in %) in Colombia in 2006 to that in 2010?
Your response must be concise. 0.93. What is the ratio of the Total Labor Force (in %) of Iraq in 2006 to that in 2010?
Keep it short and to the point. 0.95. What is the ratio of the Total Labor Force (in %) in Sri Lanka in 2006 to that in 2010?
Make the answer very short. 1.07. What is the ratio of the Total Labor Force (in %) in Sub-Saharan Africa (all income levels) in 2006 to that in 2011?
Provide a succinct answer. 0.99. What is the ratio of the Total Labor Force (in %) of Colombia in 2006 to that in 2011?
Your answer should be very brief. 0.93. What is the ratio of the Total Labor Force (in %) in Iraq in 2006 to that in 2011?
Make the answer very short. 0.95. What is the ratio of the Total Labor Force (in %) of Sri Lanka in 2006 to that in 2011?
Give a very brief answer. 1.06. What is the ratio of the Total Labor Force (in %) in Sub-Saharan Africa (all income levels) in 2006 to that in 2012?
Ensure brevity in your answer.  0.99. What is the ratio of the Total Labor Force (in %) in Colombia in 2006 to that in 2012?
Provide a succinct answer. 0.92. What is the ratio of the Total Labor Force (in %) in Iraq in 2006 to that in 2012?
Make the answer very short. 0.94. What is the ratio of the Total Labor Force (in %) of Sri Lanka in 2006 to that in 2012?
Your answer should be very brief. 1.05. What is the ratio of the Total Labor Force (in %) in Iraq in 2007 to that in 2008?
Offer a terse response. 0.99. What is the ratio of the Total Labor Force (in %) in Sri Lanka in 2007 to that in 2008?
Your answer should be very brief. 1.01. What is the ratio of the Total Labor Force (in %) of Colombia in 2007 to that in 2009?
Your answer should be very brief. 0.93. What is the ratio of the Total Labor Force (in %) of Iraq in 2007 to that in 2009?
Give a very brief answer. 0.98. What is the ratio of the Total Labor Force (in %) in Sri Lanka in 2007 to that in 2009?
Your answer should be compact. 0.97. What is the ratio of the Total Labor Force (in %) in Iraq in 2007 to that in 2010?
Offer a terse response. 0.97. What is the ratio of the Total Labor Force (in %) in Sri Lanka in 2007 to that in 2010?
Make the answer very short. 1.02. What is the ratio of the Total Labor Force (in %) of Sub-Saharan Africa (all income levels) in 2007 to that in 2011?
Your answer should be very brief. 0.99. What is the ratio of the Total Labor Force (in %) of Colombia in 2007 to that in 2011?
Provide a short and direct response. 0.91. What is the ratio of the Total Labor Force (in %) in Sri Lanka in 2007 to that in 2011?
Your response must be concise. 1.02. What is the ratio of the Total Labor Force (in %) of Sub-Saharan Africa (all income levels) in 2007 to that in 2012?
Make the answer very short. 0.99. What is the ratio of the Total Labor Force (in %) of Colombia in 2007 to that in 2012?
Ensure brevity in your answer.  0.91. What is the ratio of the Total Labor Force (in %) of Iraq in 2007 to that in 2012?
Your response must be concise. 0.95. What is the ratio of the Total Labor Force (in %) of Iraq in 2008 to that in 2009?
Provide a short and direct response. 0.99. What is the ratio of the Total Labor Force (in %) of Sri Lanka in 2008 to that in 2009?
Provide a short and direct response. 0.96. What is the ratio of the Total Labor Force (in %) in Colombia in 2008 to that in 2010?
Give a very brief answer. 0.93. What is the ratio of the Total Labor Force (in %) in Iraq in 2008 to that in 2010?
Offer a terse response. 0.98. What is the ratio of the Total Labor Force (in %) in Sri Lanka in 2008 to that in 2010?
Ensure brevity in your answer.  1.01. What is the ratio of the Total Labor Force (in %) in Sub-Saharan Africa (all income levels) in 2008 to that in 2011?
Your answer should be very brief. 1. What is the ratio of the Total Labor Force (in %) in Colombia in 2008 to that in 2011?
Ensure brevity in your answer.  0.92. What is the ratio of the Total Labor Force (in %) in Iraq in 2008 to that in 2011?
Offer a very short reply. 0.97. What is the ratio of the Total Labor Force (in %) of Sub-Saharan Africa (all income levels) in 2008 to that in 2012?
Ensure brevity in your answer.  0.99. What is the ratio of the Total Labor Force (in %) in Colombia in 2008 to that in 2012?
Your response must be concise. 0.92. What is the ratio of the Total Labor Force (in %) of Sri Lanka in 2008 to that in 2012?
Offer a very short reply. 1. What is the ratio of the Total Labor Force (in %) of Colombia in 2009 to that in 2010?
Your answer should be compact. 0.98. What is the ratio of the Total Labor Force (in %) of Iraq in 2009 to that in 2010?
Make the answer very short. 0.99. What is the ratio of the Total Labor Force (in %) of Sri Lanka in 2009 to that in 2010?
Ensure brevity in your answer.  1.05. What is the ratio of the Total Labor Force (in %) of Colombia in 2009 to that in 2011?
Your answer should be compact. 0.98. What is the ratio of the Total Labor Force (in %) of Iraq in 2009 to that in 2011?
Provide a succinct answer. 0.98. What is the ratio of the Total Labor Force (in %) of Sri Lanka in 2009 to that in 2011?
Offer a very short reply. 1.04. What is the ratio of the Total Labor Force (in %) in Sub-Saharan Africa (all income levels) in 2009 to that in 2012?
Keep it short and to the point. 0.99. What is the ratio of the Total Labor Force (in %) in Colombia in 2009 to that in 2012?
Ensure brevity in your answer.  0.97. What is the ratio of the Total Labor Force (in %) in Iraq in 2009 to that in 2012?
Provide a succinct answer. 0.97. What is the ratio of the Total Labor Force (in %) in Sri Lanka in 2009 to that in 2012?
Your answer should be very brief. 1.04. What is the ratio of the Total Labor Force (in %) of Colombia in 2010 to that in 2011?
Provide a succinct answer. 0.99. What is the ratio of the Total Labor Force (in %) of Sri Lanka in 2010 to that in 2011?
Offer a very short reply. 0.99. What is the ratio of the Total Labor Force (in %) of Iraq in 2010 to that in 2012?
Provide a succinct answer. 0.99. What is the ratio of the Total Labor Force (in %) in Sub-Saharan Africa (all income levels) in 2011 to that in 2012?
Your answer should be compact. 1. What is the ratio of the Total Labor Force (in %) of Sri Lanka in 2011 to that in 2012?
Ensure brevity in your answer.  0.99. What is the difference between the highest and the second highest Total Labor Force (in %) in Sub-Saharan Africa (all income levels)?
Offer a very short reply. 0.15. What is the difference between the highest and the second highest Total Labor Force (in %) in Colombia?
Provide a succinct answer. 0.3. What is the difference between the highest and the second highest Total Labor Force (in %) of Iraq?
Give a very brief answer. 0.1. What is the difference between the highest and the second highest Total Labor Force (in %) of Sri Lanka?
Provide a short and direct response. 0.7. What is the difference between the highest and the lowest Total Labor Force (in %) in Sub-Saharan Africa (all income levels)?
Offer a very short reply. 0.86. What is the difference between the highest and the lowest Total Labor Force (in %) of Iraq?
Offer a terse response. 1.1. What is the difference between the highest and the lowest Total Labor Force (in %) of Sri Lanka?
Provide a succinct answer. 2.9. 